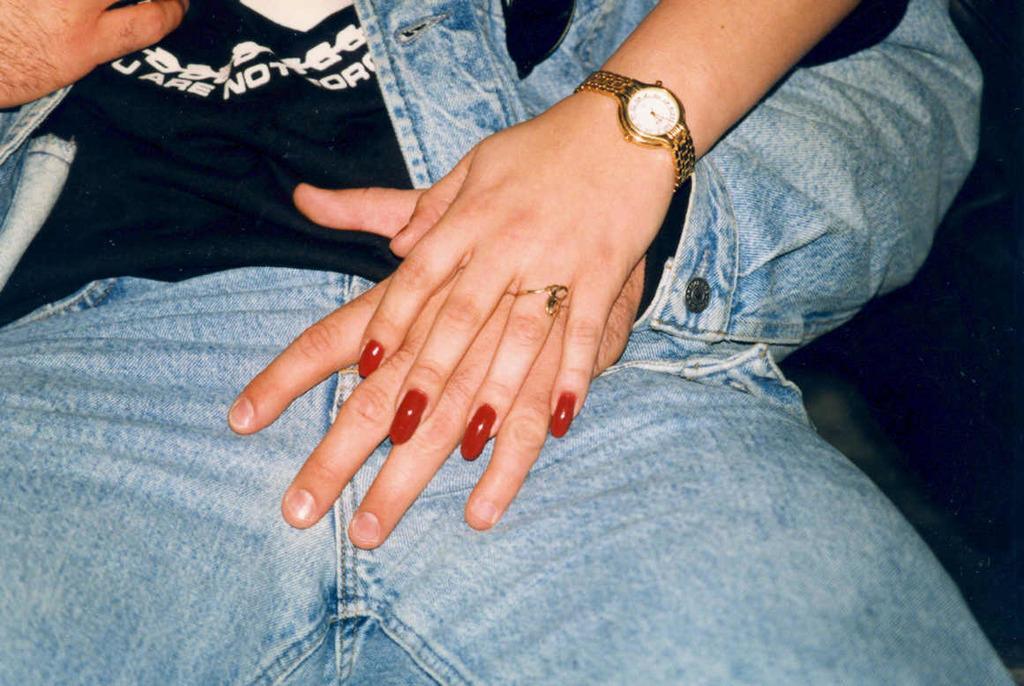In one or two sentences, can you explain what this image depicts? In the image we can see a person sitting and wearing clothes. It looks like a woman hand, wearing finger ring, nail polish to the nail and wrist watch. 